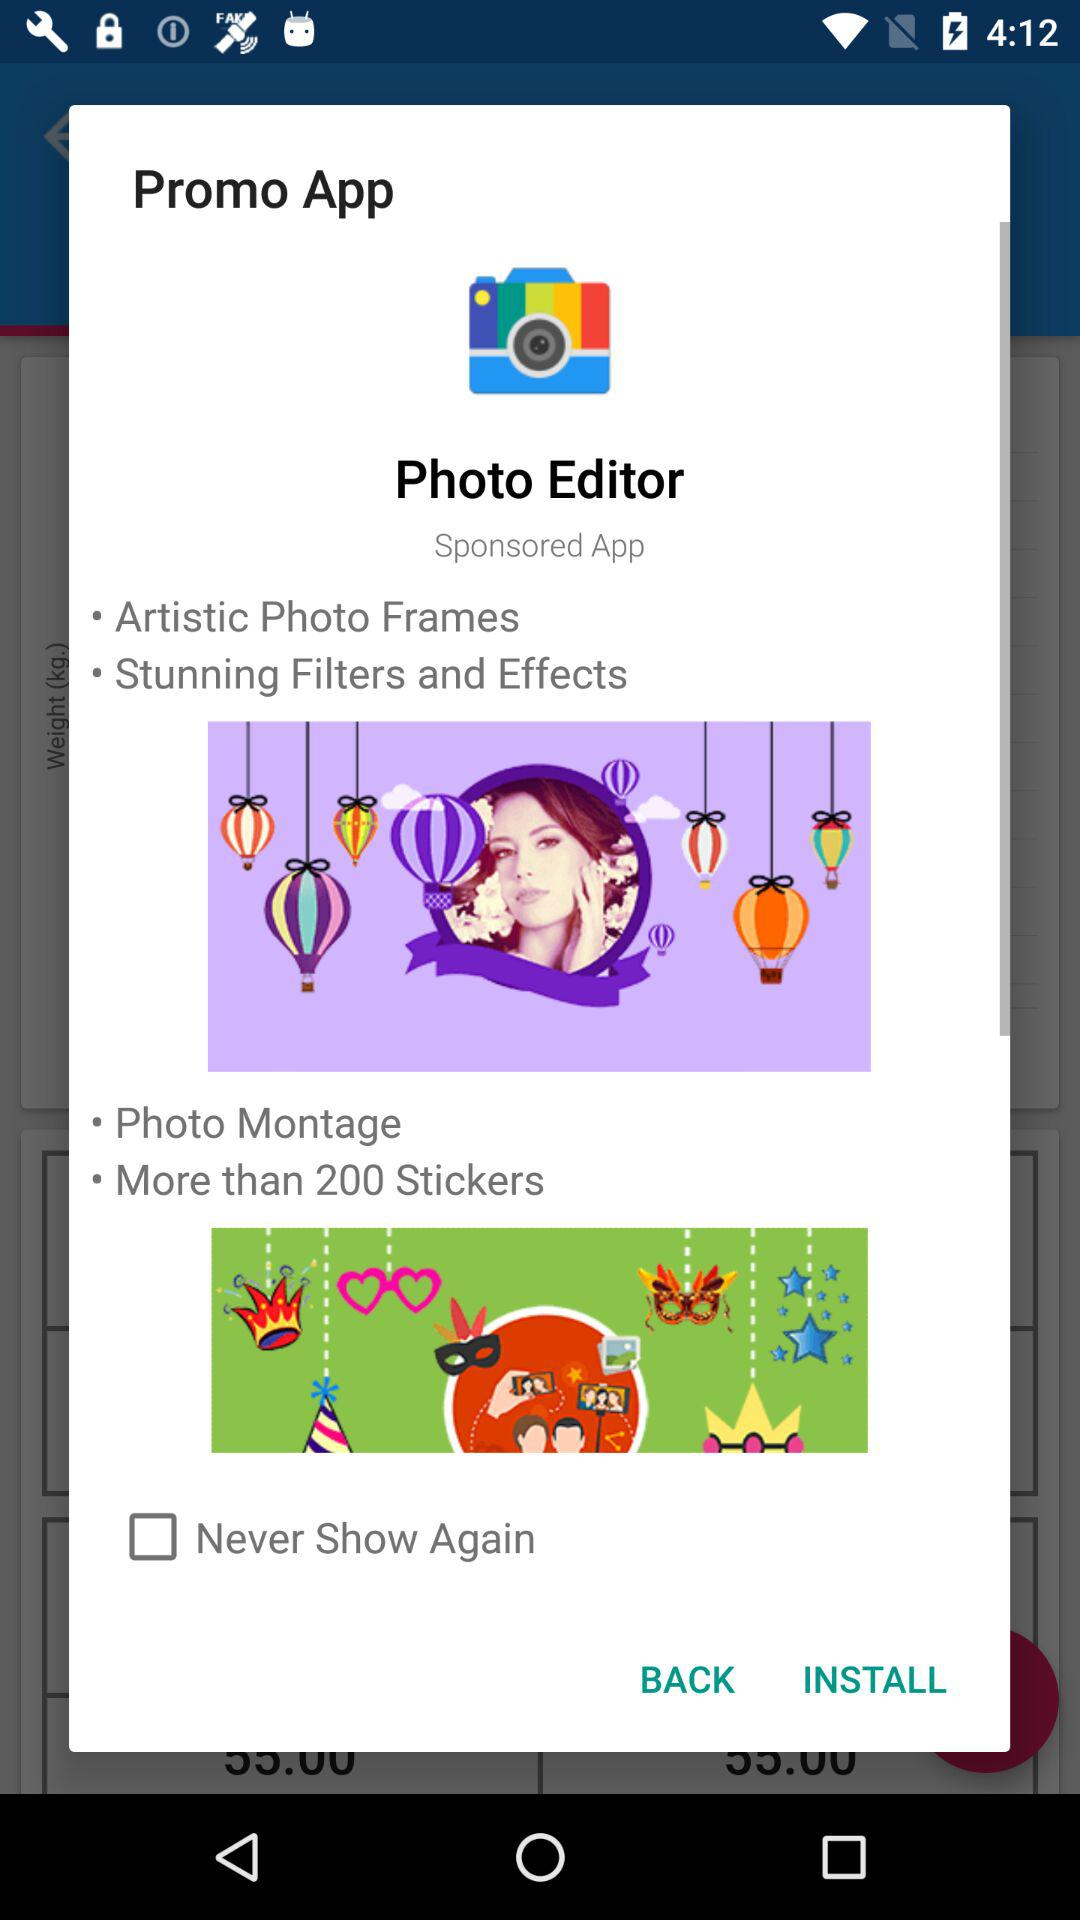How many more photo editing features are mentioned than photo montage features?
Answer the question using a single word or phrase. 2 